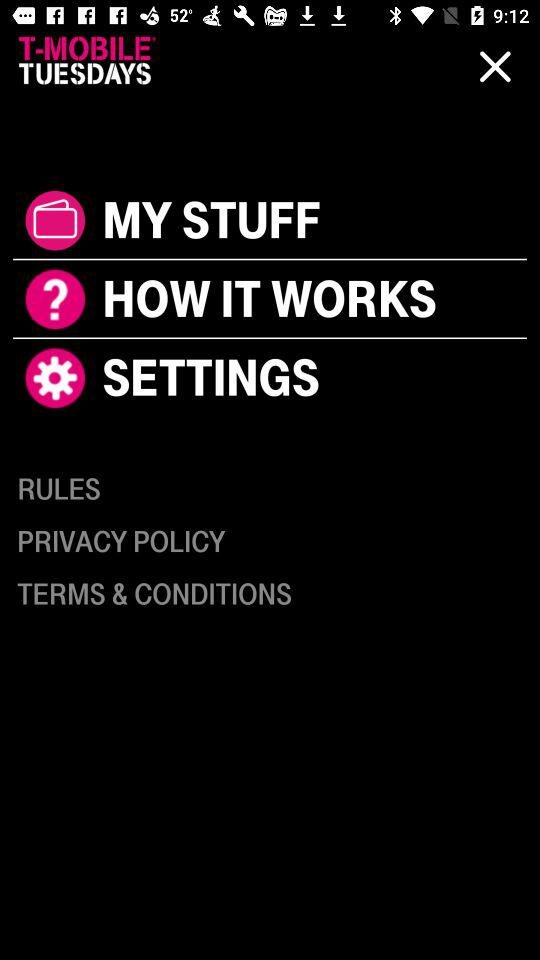What time is displayed on the countdown? The displayed time on the countdown is 5 days, 18 hours and 50 minutes. 